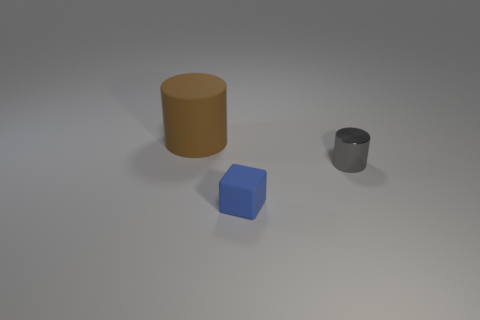Add 1 small brown shiny cubes. How many objects exist? 4 Subtract all cylinders. How many objects are left? 1 Add 1 blue blocks. How many blue blocks are left? 2 Add 2 small cyan shiny objects. How many small cyan shiny objects exist? 2 Subtract 0 blue balls. How many objects are left? 3 Subtract all small purple shiny objects. Subtract all blue matte objects. How many objects are left? 2 